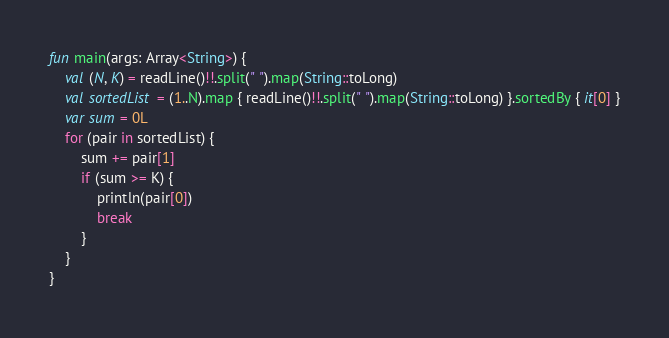<code> <loc_0><loc_0><loc_500><loc_500><_Kotlin_>fun main(args: Array<String>) {
    val (N, K) = readLine()!!.split(" ").map(String::toLong)
    val sortedList = (1..N).map { readLine()!!.split(" ").map(String::toLong) }.sortedBy { it[0] }
    var sum = 0L
    for (pair in sortedList) {
        sum += pair[1]
        if (sum >= K) {
            println(pair[0])
            break
        }
    }
}
</code> 